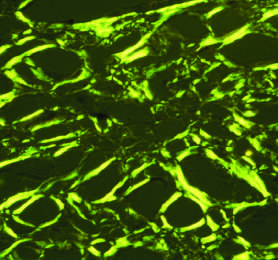does ischemic injury showing surface blebs show apple-green birefringence under polarized light, a diagnostic feature of amyloid?
Answer the question using a single word or phrase. No 